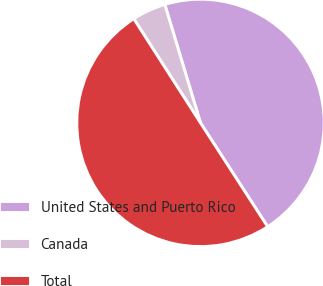Convert chart. <chart><loc_0><loc_0><loc_500><loc_500><pie_chart><fcel>United States and Puerto Rico<fcel>Canada<fcel>Total<nl><fcel>45.52%<fcel>4.41%<fcel>50.07%<nl></chart> 